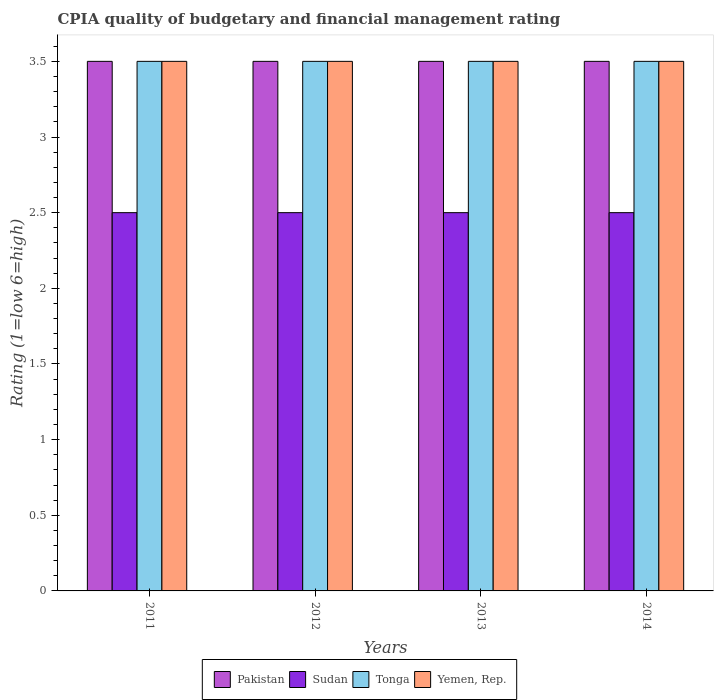How many groups of bars are there?
Offer a terse response. 4. Are the number of bars per tick equal to the number of legend labels?
Offer a terse response. Yes. How many bars are there on the 2nd tick from the left?
Your answer should be compact. 4. What is the CPIA rating in Yemen, Rep. in 2013?
Make the answer very short. 3.5. Across all years, what is the maximum CPIA rating in Pakistan?
Offer a terse response. 3.5. Across all years, what is the minimum CPIA rating in Pakistan?
Offer a very short reply. 3.5. In which year was the CPIA rating in Sudan minimum?
Provide a short and direct response. 2011. What is the difference between the CPIA rating in Tonga in 2011 and that in 2012?
Give a very brief answer. 0. What is the average CPIA rating in Tonga per year?
Provide a succinct answer. 3.5. In the year 2014, what is the difference between the CPIA rating in Yemen, Rep. and CPIA rating in Tonga?
Give a very brief answer. 0. In how many years, is the CPIA rating in Yemen, Rep. greater than 0.5?
Make the answer very short. 4. What is the ratio of the CPIA rating in Sudan in 2012 to that in 2014?
Keep it short and to the point. 1. Is the CPIA rating in Sudan in 2011 less than that in 2013?
Ensure brevity in your answer.  No. What does the 4th bar from the right in 2013 represents?
Offer a terse response. Pakistan. Is it the case that in every year, the sum of the CPIA rating in Yemen, Rep. and CPIA rating in Tonga is greater than the CPIA rating in Sudan?
Your response must be concise. Yes. How many years are there in the graph?
Your response must be concise. 4. What is the difference between two consecutive major ticks on the Y-axis?
Ensure brevity in your answer.  0.5. Are the values on the major ticks of Y-axis written in scientific E-notation?
Give a very brief answer. No. Where does the legend appear in the graph?
Ensure brevity in your answer.  Bottom center. How are the legend labels stacked?
Provide a succinct answer. Horizontal. What is the title of the graph?
Keep it short and to the point. CPIA quality of budgetary and financial management rating. What is the label or title of the X-axis?
Keep it short and to the point. Years. What is the label or title of the Y-axis?
Your answer should be very brief. Rating (1=low 6=high). What is the Rating (1=low 6=high) of Pakistan in 2011?
Offer a very short reply. 3.5. What is the Rating (1=low 6=high) of Yemen, Rep. in 2011?
Ensure brevity in your answer.  3.5. What is the Rating (1=low 6=high) of Sudan in 2012?
Keep it short and to the point. 2.5. What is the Rating (1=low 6=high) in Sudan in 2013?
Your answer should be compact. 2.5. What is the Rating (1=low 6=high) in Yemen, Rep. in 2013?
Offer a very short reply. 3.5. What is the Rating (1=low 6=high) in Pakistan in 2014?
Ensure brevity in your answer.  3.5. Across all years, what is the maximum Rating (1=low 6=high) in Tonga?
Your answer should be compact. 3.5. Across all years, what is the maximum Rating (1=low 6=high) in Yemen, Rep.?
Offer a terse response. 3.5. Across all years, what is the minimum Rating (1=low 6=high) in Pakistan?
Offer a very short reply. 3.5. Across all years, what is the minimum Rating (1=low 6=high) in Sudan?
Your answer should be compact. 2.5. Across all years, what is the minimum Rating (1=low 6=high) of Tonga?
Provide a succinct answer. 3.5. What is the total Rating (1=low 6=high) in Sudan in the graph?
Keep it short and to the point. 10. What is the total Rating (1=low 6=high) in Tonga in the graph?
Provide a short and direct response. 14. What is the total Rating (1=low 6=high) in Yemen, Rep. in the graph?
Make the answer very short. 14. What is the difference between the Rating (1=low 6=high) of Tonga in 2011 and that in 2012?
Ensure brevity in your answer.  0. What is the difference between the Rating (1=low 6=high) in Yemen, Rep. in 2011 and that in 2012?
Your answer should be very brief. 0. What is the difference between the Rating (1=low 6=high) of Sudan in 2011 and that in 2013?
Give a very brief answer. 0. What is the difference between the Rating (1=low 6=high) of Yemen, Rep. in 2011 and that in 2013?
Your answer should be very brief. 0. What is the difference between the Rating (1=low 6=high) in Pakistan in 2011 and that in 2014?
Your answer should be compact. 0. What is the difference between the Rating (1=low 6=high) of Yemen, Rep. in 2011 and that in 2014?
Provide a succinct answer. 0. What is the difference between the Rating (1=low 6=high) in Yemen, Rep. in 2012 and that in 2014?
Ensure brevity in your answer.  0. What is the difference between the Rating (1=low 6=high) in Tonga in 2013 and that in 2014?
Keep it short and to the point. 0. What is the difference between the Rating (1=low 6=high) of Yemen, Rep. in 2013 and that in 2014?
Keep it short and to the point. 0. What is the difference between the Rating (1=low 6=high) of Pakistan in 2011 and the Rating (1=low 6=high) of Sudan in 2012?
Offer a very short reply. 1. What is the difference between the Rating (1=low 6=high) in Tonga in 2011 and the Rating (1=low 6=high) in Yemen, Rep. in 2012?
Your answer should be compact. 0. What is the difference between the Rating (1=low 6=high) of Pakistan in 2011 and the Rating (1=low 6=high) of Sudan in 2013?
Provide a short and direct response. 1. What is the difference between the Rating (1=low 6=high) in Sudan in 2011 and the Rating (1=low 6=high) in Tonga in 2013?
Provide a short and direct response. -1. What is the difference between the Rating (1=low 6=high) of Tonga in 2011 and the Rating (1=low 6=high) of Yemen, Rep. in 2013?
Provide a short and direct response. 0. What is the difference between the Rating (1=low 6=high) in Sudan in 2011 and the Rating (1=low 6=high) in Tonga in 2014?
Offer a terse response. -1. What is the difference between the Rating (1=low 6=high) in Pakistan in 2012 and the Rating (1=low 6=high) in Sudan in 2013?
Give a very brief answer. 1. What is the difference between the Rating (1=low 6=high) of Sudan in 2012 and the Rating (1=low 6=high) of Tonga in 2013?
Keep it short and to the point. -1. What is the difference between the Rating (1=low 6=high) in Sudan in 2012 and the Rating (1=low 6=high) in Yemen, Rep. in 2013?
Provide a succinct answer. -1. What is the difference between the Rating (1=low 6=high) in Tonga in 2012 and the Rating (1=low 6=high) in Yemen, Rep. in 2013?
Provide a short and direct response. 0. What is the difference between the Rating (1=low 6=high) in Pakistan in 2012 and the Rating (1=low 6=high) in Sudan in 2014?
Give a very brief answer. 1. What is the difference between the Rating (1=low 6=high) of Pakistan in 2012 and the Rating (1=low 6=high) of Tonga in 2014?
Keep it short and to the point. 0. What is the difference between the Rating (1=low 6=high) of Pakistan in 2012 and the Rating (1=low 6=high) of Yemen, Rep. in 2014?
Offer a terse response. 0. What is the difference between the Rating (1=low 6=high) in Sudan in 2012 and the Rating (1=low 6=high) in Tonga in 2014?
Keep it short and to the point. -1. What is the difference between the Rating (1=low 6=high) in Sudan in 2012 and the Rating (1=low 6=high) in Yemen, Rep. in 2014?
Your response must be concise. -1. What is the difference between the Rating (1=low 6=high) of Tonga in 2012 and the Rating (1=low 6=high) of Yemen, Rep. in 2014?
Offer a terse response. 0. What is the difference between the Rating (1=low 6=high) in Pakistan in 2013 and the Rating (1=low 6=high) in Sudan in 2014?
Your response must be concise. 1. What is the difference between the Rating (1=low 6=high) in Pakistan in 2013 and the Rating (1=low 6=high) in Tonga in 2014?
Your answer should be very brief. 0. What is the difference between the Rating (1=low 6=high) in Sudan in 2013 and the Rating (1=low 6=high) in Tonga in 2014?
Provide a succinct answer. -1. What is the average Rating (1=low 6=high) of Pakistan per year?
Your response must be concise. 3.5. What is the average Rating (1=low 6=high) of Sudan per year?
Provide a short and direct response. 2.5. What is the average Rating (1=low 6=high) of Tonga per year?
Keep it short and to the point. 3.5. In the year 2011, what is the difference between the Rating (1=low 6=high) in Pakistan and Rating (1=low 6=high) in Sudan?
Make the answer very short. 1. In the year 2011, what is the difference between the Rating (1=low 6=high) in Sudan and Rating (1=low 6=high) in Yemen, Rep.?
Provide a short and direct response. -1. In the year 2011, what is the difference between the Rating (1=low 6=high) in Tonga and Rating (1=low 6=high) in Yemen, Rep.?
Make the answer very short. 0. In the year 2012, what is the difference between the Rating (1=low 6=high) of Pakistan and Rating (1=low 6=high) of Sudan?
Make the answer very short. 1. In the year 2012, what is the difference between the Rating (1=low 6=high) of Sudan and Rating (1=low 6=high) of Tonga?
Provide a short and direct response. -1. In the year 2012, what is the difference between the Rating (1=low 6=high) of Sudan and Rating (1=low 6=high) of Yemen, Rep.?
Your answer should be very brief. -1. In the year 2012, what is the difference between the Rating (1=low 6=high) of Tonga and Rating (1=low 6=high) of Yemen, Rep.?
Your answer should be compact. 0. In the year 2013, what is the difference between the Rating (1=low 6=high) in Pakistan and Rating (1=low 6=high) in Sudan?
Keep it short and to the point. 1. In the year 2013, what is the difference between the Rating (1=low 6=high) of Sudan and Rating (1=low 6=high) of Tonga?
Provide a succinct answer. -1. In the year 2013, what is the difference between the Rating (1=low 6=high) in Sudan and Rating (1=low 6=high) in Yemen, Rep.?
Give a very brief answer. -1. In the year 2014, what is the difference between the Rating (1=low 6=high) in Pakistan and Rating (1=low 6=high) in Yemen, Rep.?
Keep it short and to the point. 0. In the year 2014, what is the difference between the Rating (1=low 6=high) of Sudan and Rating (1=low 6=high) of Tonga?
Offer a terse response. -1. In the year 2014, what is the difference between the Rating (1=low 6=high) of Sudan and Rating (1=low 6=high) of Yemen, Rep.?
Keep it short and to the point. -1. What is the ratio of the Rating (1=low 6=high) in Sudan in 2011 to that in 2012?
Ensure brevity in your answer.  1. What is the ratio of the Rating (1=low 6=high) in Tonga in 2011 to that in 2012?
Give a very brief answer. 1. What is the ratio of the Rating (1=low 6=high) in Sudan in 2011 to that in 2013?
Your answer should be compact. 1. What is the ratio of the Rating (1=low 6=high) in Pakistan in 2011 to that in 2014?
Provide a short and direct response. 1. What is the ratio of the Rating (1=low 6=high) in Sudan in 2011 to that in 2014?
Offer a very short reply. 1. What is the ratio of the Rating (1=low 6=high) in Pakistan in 2012 to that in 2013?
Your answer should be compact. 1. What is the ratio of the Rating (1=low 6=high) in Sudan in 2012 to that in 2013?
Your answer should be compact. 1. What is the ratio of the Rating (1=low 6=high) in Yemen, Rep. in 2012 to that in 2013?
Offer a terse response. 1. What is the ratio of the Rating (1=low 6=high) of Sudan in 2012 to that in 2014?
Your response must be concise. 1. What is the ratio of the Rating (1=low 6=high) in Tonga in 2012 to that in 2014?
Offer a very short reply. 1. What is the ratio of the Rating (1=low 6=high) of Pakistan in 2013 to that in 2014?
Offer a terse response. 1. What is the ratio of the Rating (1=low 6=high) in Sudan in 2013 to that in 2014?
Provide a succinct answer. 1. What is the ratio of the Rating (1=low 6=high) of Tonga in 2013 to that in 2014?
Make the answer very short. 1. What is the ratio of the Rating (1=low 6=high) in Yemen, Rep. in 2013 to that in 2014?
Ensure brevity in your answer.  1. What is the difference between the highest and the second highest Rating (1=low 6=high) of Tonga?
Give a very brief answer. 0. What is the difference between the highest and the lowest Rating (1=low 6=high) in Pakistan?
Make the answer very short. 0. What is the difference between the highest and the lowest Rating (1=low 6=high) in Tonga?
Your response must be concise. 0. What is the difference between the highest and the lowest Rating (1=low 6=high) of Yemen, Rep.?
Your response must be concise. 0. 